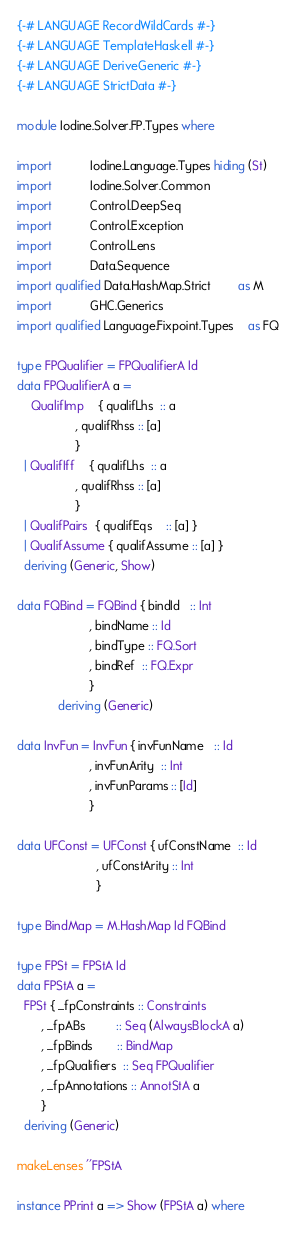<code> <loc_0><loc_0><loc_500><loc_500><_Haskell_>{-# LANGUAGE RecordWildCards #-}
{-# LANGUAGE TemplateHaskell #-}
{-# LANGUAGE DeriveGeneric #-}
{-# LANGUAGE StrictData #-}

module Iodine.Solver.FP.Types where

import           Iodine.Language.Types hiding (St)
import           Iodine.Solver.Common
import           Control.DeepSeq
import           Control.Exception
import           Control.Lens
import           Data.Sequence
import qualified Data.HashMap.Strict        as M
import           GHC.Generics
import qualified Language.Fixpoint.Types    as FQ

type FPQualifier = FPQualifierA Id
data FPQualifierA a =
    QualifImp    { qualifLhs  :: a
                 , qualifRhss :: [a]
                 }
  | QualifIff    { qualifLhs  :: a
                 , qualifRhss :: [a]
                 }
  | QualifPairs  { qualifEqs    :: [a] }
  | QualifAssume { qualifAssume :: [a] }
  deriving (Generic, Show)

data FQBind = FQBind { bindId   :: Int
                     , bindName :: Id
                     , bindType :: FQ.Sort
                     , bindRef  :: FQ.Expr
                     }
            deriving (Generic)

data InvFun = InvFun { invFunName   :: Id
                     , invFunArity  :: Int
                     , invFunParams :: [Id]
                     }

data UFConst = UFConst { ufConstName  :: Id
                       , ufConstArity :: Int
                       }

type BindMap = M.HashMap Id FQBind

type FPSt = FPStA Id
data FPStA a =
  FPSt { _fpConstraints :: Constraints
       , _fpABs         :: Seq (AlwaysBlockA a)
       , _fpBinds       :: BindMap
       , _fpQualifiers  :: Seq FPQualifier
       , _fpAnnotations :: AnnotStA a
       }
  deriving (Generic)

makeLenses ''FPStA

instance PPrint a => Show (FPStA a) where</code> 